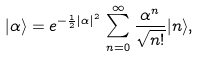<formula> <loc_0><loc_0><loc_500><loc_500>| \alpha \rangle = e ^ { - \frac { 1 } { 2 } | \alpha | ^ { 2 } } \, \sum _ { n = 0 } ^ { \infty } \frac { \alpha ^ { n } } { \sqrt { n ! } } | n \rangle ,</formula> 